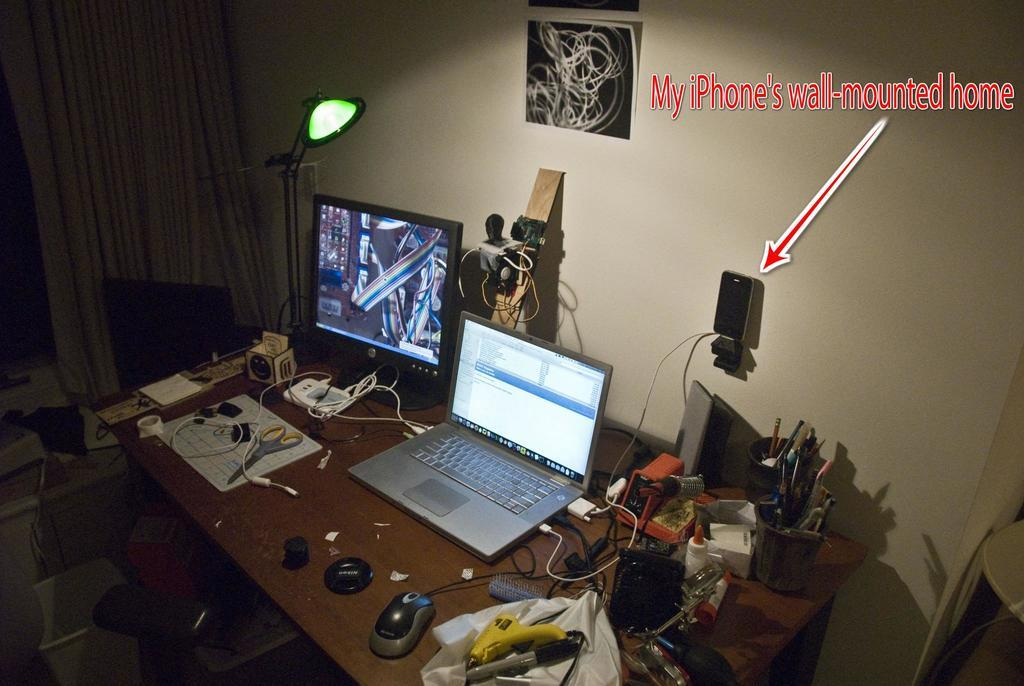<image>
Offer a succinct explanation of the picture presented. a cluttered desk with a red arrow under a sentence reading 'my Phone's wall-mounted home' 